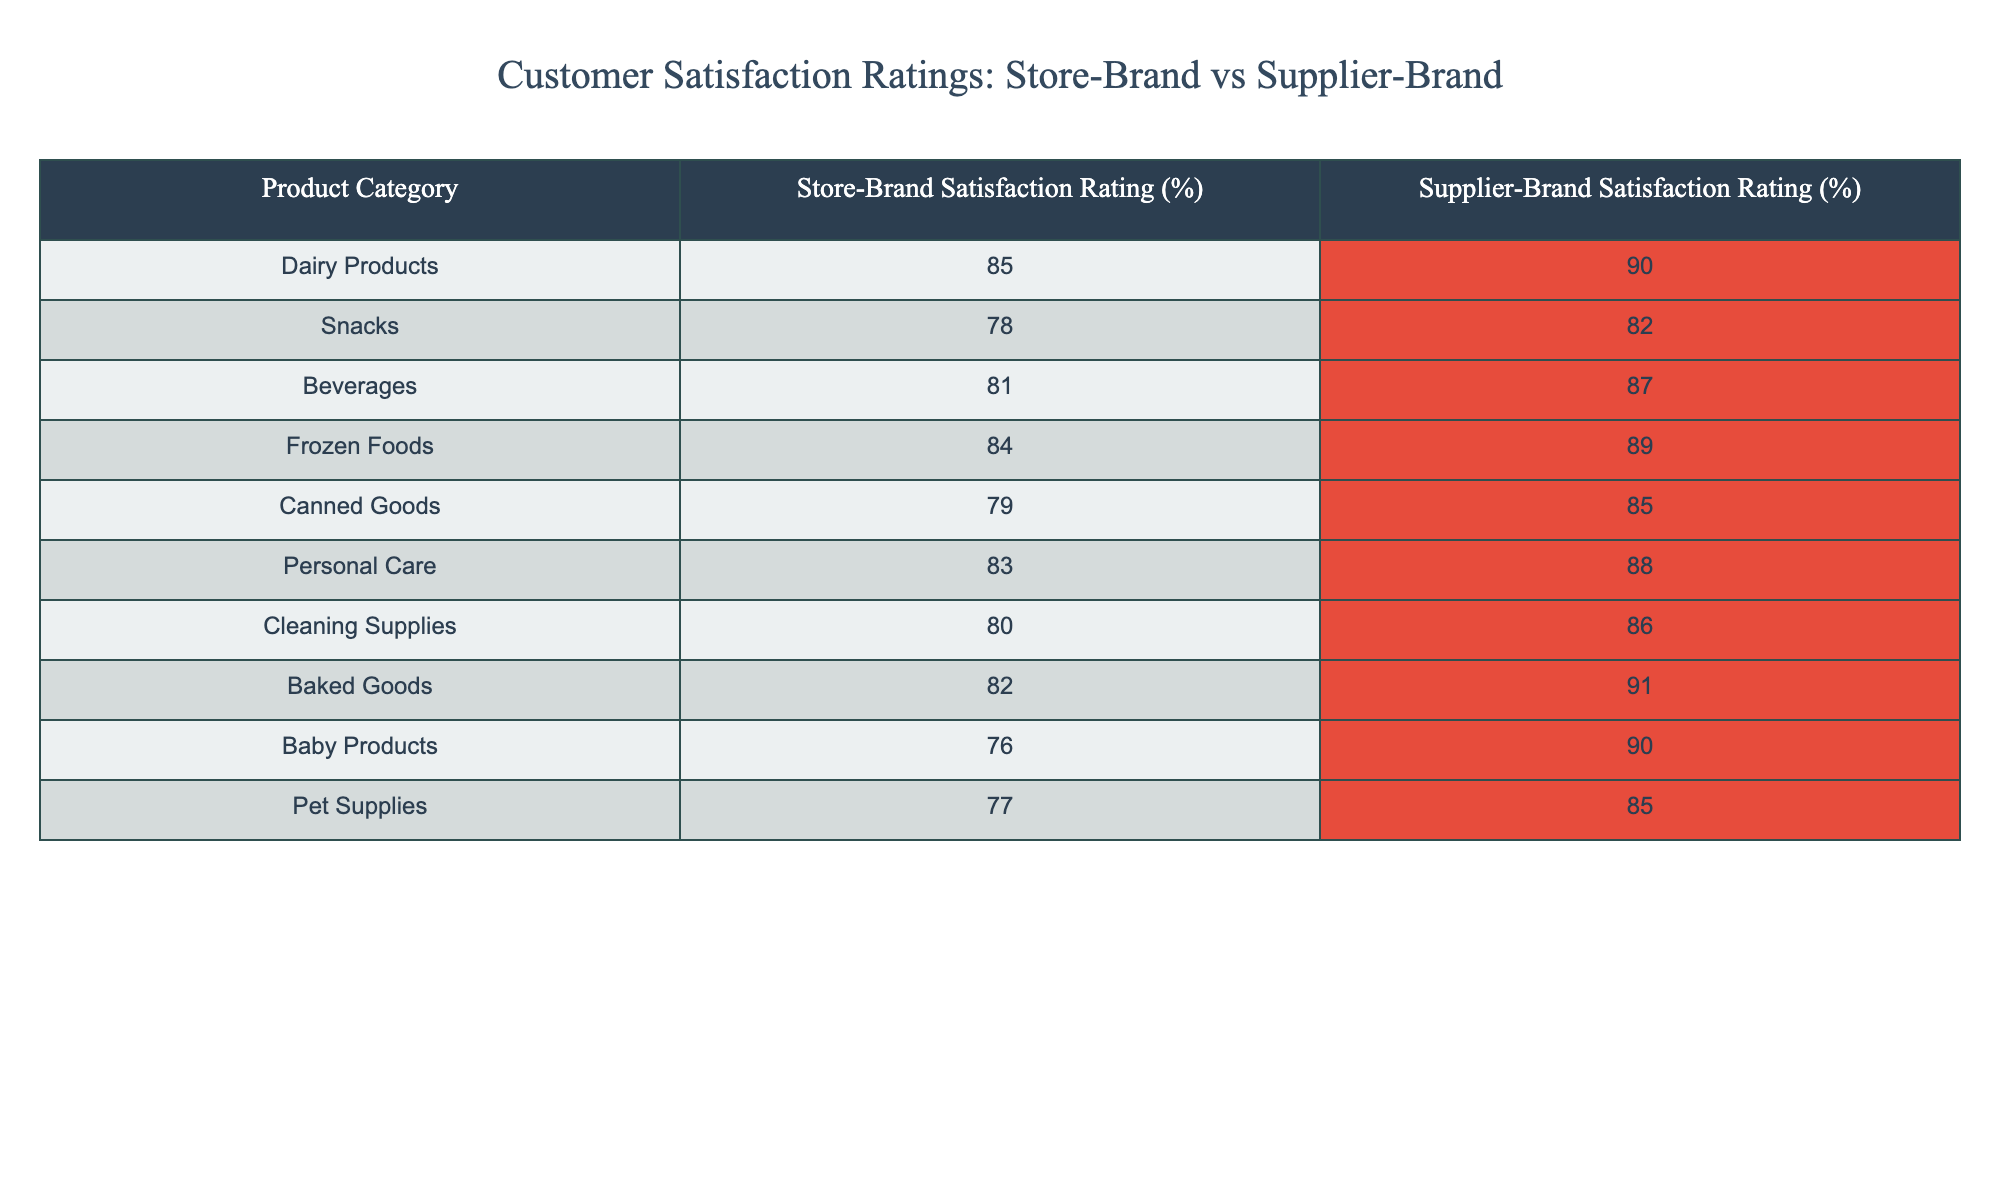What is the satisfaction rating for store-brand dairy products? The table shows that the satisfaction rating for store-brand dairy products is 85%.
Answer: 85% What is the difference in satisfaction ratings between store-brand and supplier-brand for snacks? The satisfaction rating for store-brand snacks is 78%, while for supplier-brand snacks it is 82%. The difference is calculated as 82% - 78% = 4%.
Answer: 4% Is the satisfaction rating for any store-brand product higher than its supplier-brand counterpart? By reviewing the table, we see that no store-brand product has a higher satisfaction rating than its supplier-brand. All store-brand ratings are lower than supplier-brand ratings.
Answer: No Which product category has the highest satisfaction rating for supplier-brand products? Looking through the table, the supplier-brand satisfaction rating is highest for baked goods at 91%.
Answer: 91% What is the average satisfaction rating for store-brand products? To calculate the average, sum the store-brand satisfaction ratings: 85 + 78 + 81 + 84 + 79 + 83 + 80 + 82 + 76 + 77 = 804. There are 10 product categories, so the average is 804 / 10 = 80.4%.
Answer: 80.4% In which product category is the gap between store-brand and supplier-brand satisfaction ratings the largest? To find the largest gap, we look at the differences calculated for each category: Dairy (5%), Snacks (4%), Beverages (6%), Frozen Foods (5%), Canned Goods (6%), Personal Care (5%), Cleaning Supplies (6%), Baked Goods (9%), Baby Products (14%), Pet Supplies (8%). The largest gap is found in baby products: 14%.
Answer: Baby Products Are store-brand personal care products perceived to be better than store-brand pet supplies in terms of customer satisfaction? The satisfaction rating for store-brand personal care products is 83%, which is higher than the 77% rating for store-brand pet supplies. Thus, store-brand personal care products are perceived to be better.
Answer: Yes What percentage of the total product categories have a store-brand satisfaction rating below 80%? From the table, out of 10 product categories, baby products (76%) and pet supplies (77%) have store-brand ratings below 80%, totaling 2 out of 10. Therefore, it’s 2/10 = 20%.
Answer: 20% 